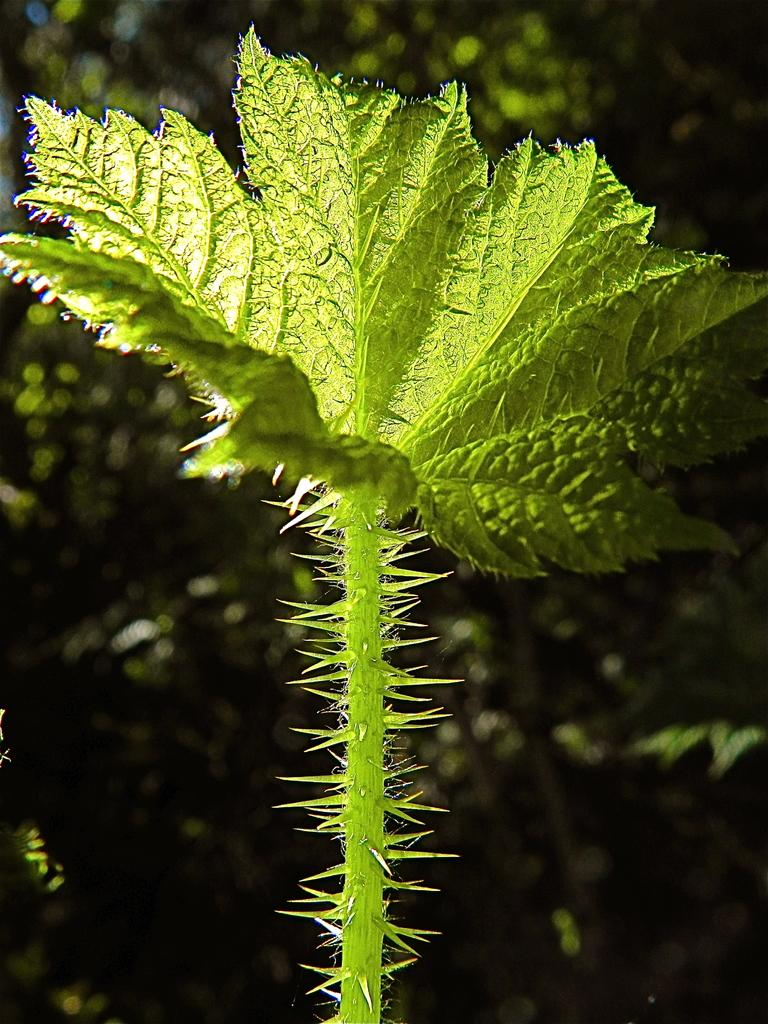What type of plant is visible in the image? There is a plant in the image, and it has thorns and leaves. What can be seen in the background of the image? There are trees in the background of the image. How is the background of the image depicted? The background is blurred. Where is the rod used for playing in the image? There is no rod or playground equipment present in the image. How much salt is sprinkled on the plant in the image? There is no salt present in the image; it is a plant with thorns and leaves. 